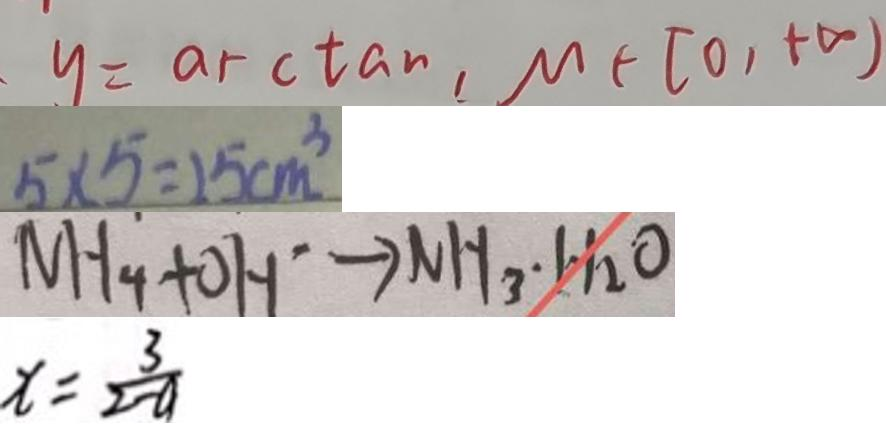<formula> <loc_0><loc_0><loc_500><loc_500>y = \arctan , \mu \in [ 0 , + \infty ) 
 5 \times 5 = 2 5 c m ^ { 3 } 
 N H _ { 4 } + O H ^ { \cdot } \rightarrow N H _ { 3 } \cdot H _ { 2 } O 
 x = \frac { 3 } { 2 - a }</formula> 